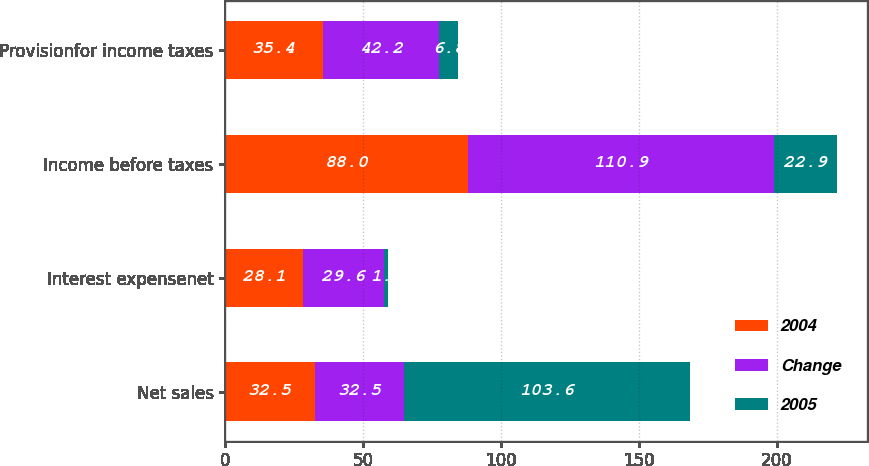Convert chart. <chart><loc_0><loc_0><loc_500><loc_500><stacked_bar_chart><ecel><fcel>Net sales<fcel>Interest expensenet<fcel>Income before taxes<fcel>Provisionfor income taxes<nl><fcel>2004<fcel>32.5<fcel>28.1<fcel>88<fcel>35.4<nl><fcel>Change<fcel>32.5<fcel>29.6<fcel>110.9<fcel>42.2<nl><fcel>2005<fcel>103.6<fcel>1.5<fcel>22.9<fcel>6.8<nl></chart> 